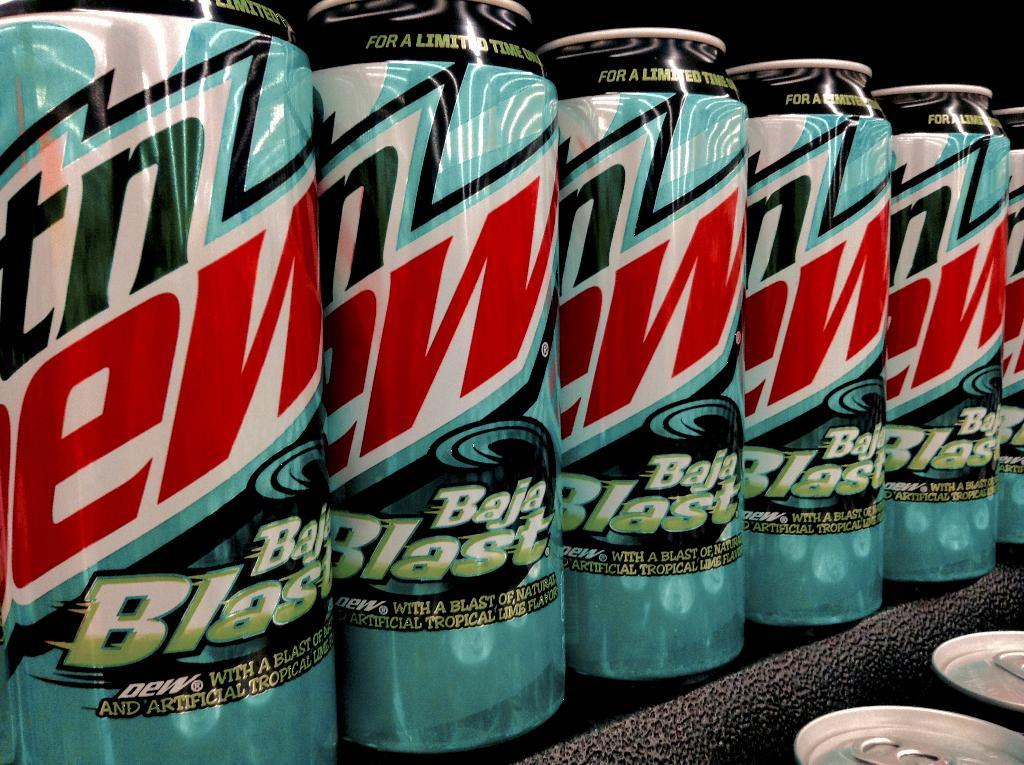<image>
Relay a brief, clear account of the picture shown. several cans of mountain dew on a shelf 